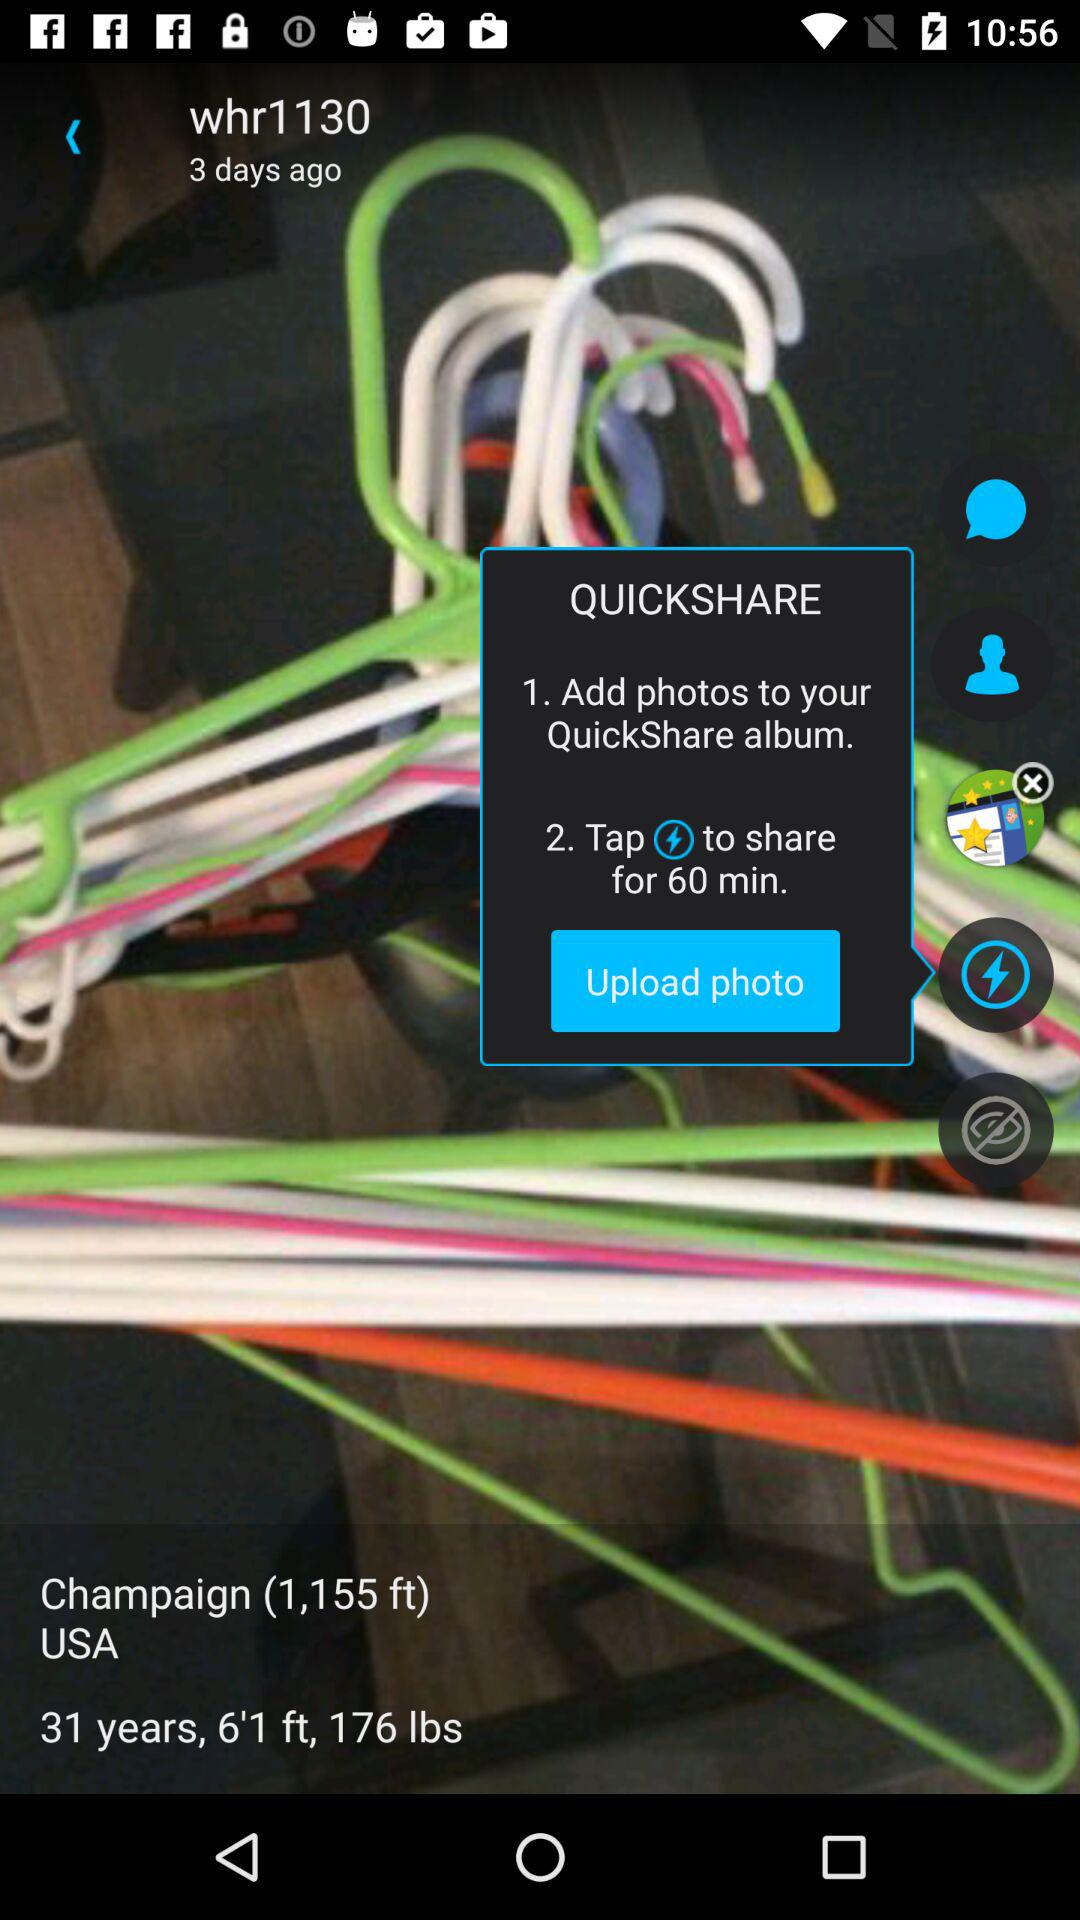For how many minutes can you share? You can share for 60 minutes. 